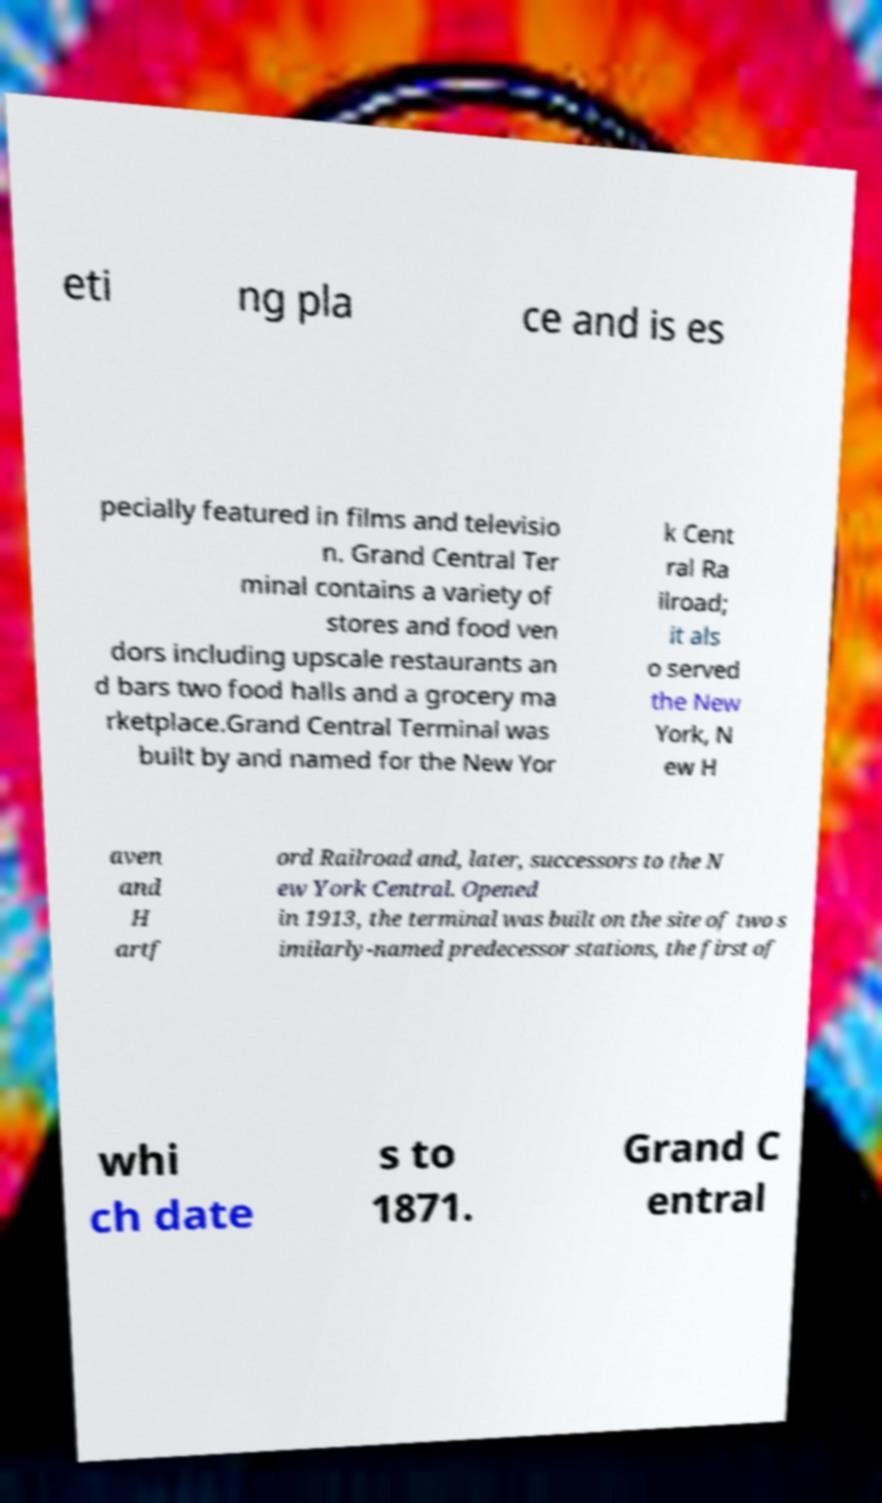Please read and relay the text visible in this image. What does it say? eti ng pla ce and is es pecially featured in films and televisio n. Grand Central Ter minal contains a variety of stores and food ven dors including upscale restaurants an d bars two food halls and a grocery ma rketplace.Grand Central Terminal was built by and named for the New Yor k Cent ral Ra ilroad; it als o served the New York, N ew H aven and H artf ord Railroad and, later, successors to the N ew York Central. Opened in 1913, the terminal was built on the site of two s imilarly-named predecessor stations, the first of whi ch date s to 1871. Grand C entral 